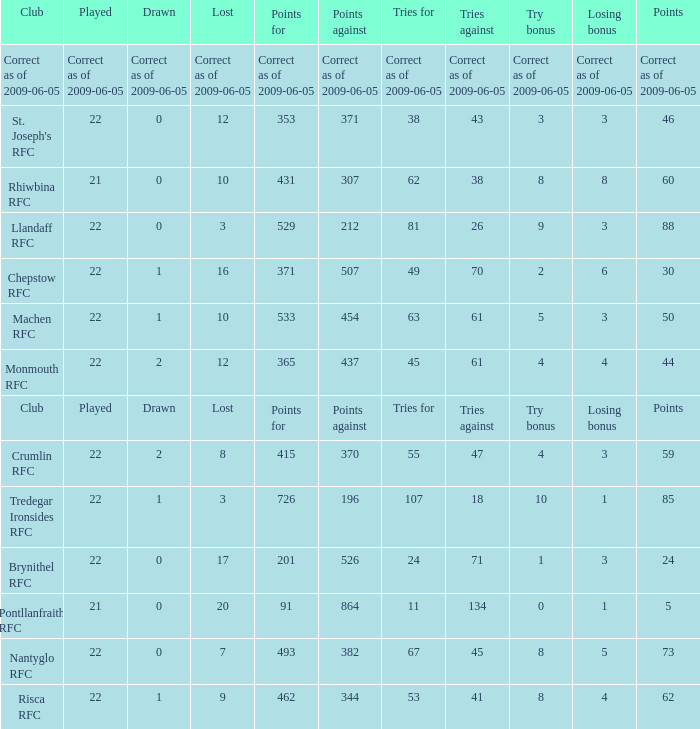If the losing bonus was 6, what is the tries for? 49.0. 